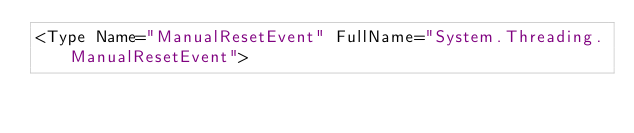Convert code to text. <code><loc_0><loc_0><loc_500><loc_500><_XML_><Type Name="ManualResetEvent" FullName="System.Threading.ManualResetEvent"></code> 